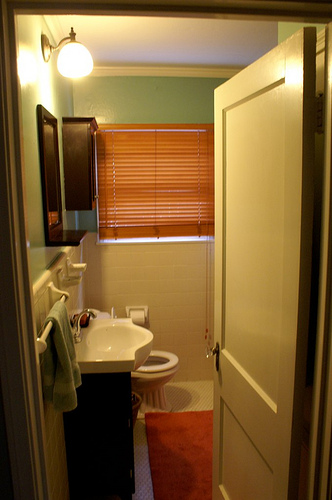What kind of ambiance does this bathroom create? The bathroom creates a cozy and inviting ambiance. The light teal walls, along with the warm wooden elements and soft lighting, combine to give a comforting and homey feel. Can you list any possible improvements to enhance the bathroom experience? To enhance the experience, consider the following improvements: adding more storage solutions like shelves or cabinets, updating the lighting to more modern fixtures, installing a larger mirror for better functionality, and perhaps incorporating some plants or decor items to add a touch of nature and liveliness to the space. Imagine if this bathroom were part of a magical forest. How would it change? In a magical forest setting, this bathroom would be transformed into a whimsical retreat. The walls might be covered with enchanted vines and flowers that glow softly, the sink would pour out sparkling, crystal-clear water, and the light fixtures would be made of luminescent mushrooms. The mirror could show not only your reflection but also offer glimpses of enchanted creatures wandering in the forest. 